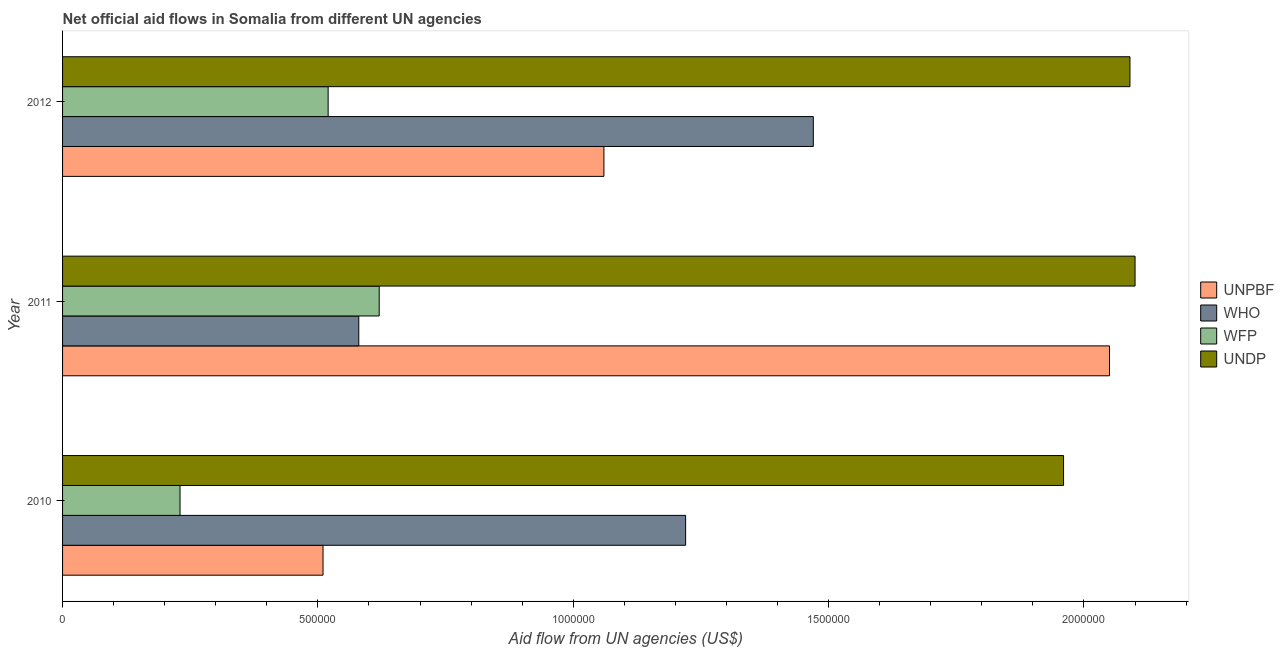How many different coloured bars are there?
Provide a succinct answer. 4. How many groups of bars are there?
Give a very brief answer. 3. Are the number of bars per tick equal to the number of legend labels?
Ensure brevity in your answer.  Yes. Are the number of bars on each tick of the Y-axis equal?
Provide a short and direct response. Yes. How many bars are there on the 3rd tick from the top?
Give a very brief answer. 4. What is the amount of aid given by who in 2010?
Your answer should be very brief. 1.22e+06. Across all years, what is the maximum amount of aid given by wfp?
Make the answer very short. 6.20e+05. Across all years, what is the minimum amount of aid given by undp?
Your response must be concise. 1.96e+06. In which year was the amount of aid given by undp minimum?
Your response must be concise. 2010. What is the total amount of aid given by wfp in the graph?
Keep it short and to the point. 1.37e+06. What is the difference between the amount of aid given by wfp in 2010 and that in 2012?
Offer a very short reply. -2.90e+05. What is the difference between the amount of aid given by unpbf in 2010 and the amount of aid given by wfp in 2011?
Give a very brief answer. -1.10e+05. What is the average amount of aid given by wfp per year?
Offer a very short reply. 4.57e+05. In the year 2012, what is the difference between the amount of aid given by undp and amount of aid given by wfp?
Offer a terse response. 1.57e+06. What is the ratio of the amount of aid given by unpbf in 2010 to that in 2012?
Ensure brevity in your answer.  0.48. Is the amount of aid given by wfp in 2011 less than that in 2012?
Keep it short and to the point. No. What is the difference between the highest and the second highest amount of aid given by undp?
Your response must be concise. 10000. What is the difference between the highest and the lowest amount of aid given by unpbf?
Your response must be concise. 1.54e+06. In how many years, is the amount of aid given by wfp greater than the average amount of aid given by wfp taken over all years?
Your response must be concise. 2. What does the 3rd bar from the top in 2012 represents?
Your response must be concise. WHO. What does the 2nd bar from the bottom in 2011 represents?
Keep it short and to the point. WHO. How many years are there in the graph?
Your answer should be very brief. 3. What is the difference between two consecutive major ticks on the X-axis?
Provide a short and direct response. 5.00e+05. Are the values on the major ticks of X-axis written in scientific E-notation?
Your answer should be very brief. No. Does the graph contain any zero values?
Offer a terse response. No. Does the graph contain grids?
Your response must be concise. No. What is the title of the graph?
Your answer should be very brief. Net official aid flows in Somalia from different UN agencies. What is the label or title of the X-axis?
Give a very brief answer. Aid flow from UN agencies (US$). What is the Aid flow from UN agencies (US$) in UNPBF in 2010?
Provide a short and direct response. 5.10e+05. What is the Aid flow from UN agencies (US$) of WHO in 2010?
Make the answer very short. 1.22e+06. What is the Aid flow from UN agencies (US$) in WFP in 2010?
Offer a very short reply. 2.30e+05. What is the Aid flow from UN agencies (US$) in UNDP in 2010?
Provide a short and direct response. 1.96e+06. What is the Aid flow from UN agencies (US$) in UNPBF in 2011?
Keep it short and to the point. 2.05e+06. What is the Aid flow from UN agencies (US$) in WHO in 2011?
Give a very brief answer. 5.80e+05. What is the Aid flow from UN agencies (US$) in WFP in 2011?
Your answer should be compact. 6.20e+05. What is the Aid flow from UN agencies (US$) in UNDP in 2011?
Your answer should be compact. 2.10e+06. What is the Aid flow from UN agencies (US$) in UNPBF in 2012?
Offer a terse response. 1.06e+06. What is the Aid flow from UN agencies (US$) of WHO in 2012?
Offer a very short reply. 1.47e+06. What is the Aid flow from UN agencies (US$) in WFP in 2012?
Make the answer very short. 5.20e+05. What is the Aid flow from UN agencies (US$) in UNDP in 2012?
Keep it short and to the point. 2.09e+06. Across all years, what is the maximum Aid flow from UN agencies (US$) of UNPBF?
Make the answer very short. 2.05e+06. Across all years, what is the maximum Aid flow from UN agencies (US$) of WHO?
Make the answer very short. 1.47e+06. Across all years, what is the maximum Aid flow from UN agencies (US$) of WFP?
Your answer should be very brief. 6.20e+05. Across all years, what is the maximum Aid flow from UN agencies (US$) in UNDP?
Offer a very short reply. 2.10e+06. Across all years, what is the minimum Aid flow from UN agencies (US$) of UNPBF?
Your answer should be very brief. 5.10e+05. Across all years, what is the minimum Aid flow from UN agencies (US$) in WHO?
Your answer should be compact. 5.80e+05. Across all years, what is the minimum Aid flow from UN agencies (US$) of UNDP?
Ensure brevity in your answer.  1.96e+06. What is the total Aid flow from UN agencies (US$) of UNPBF in the graph?
Offer a very short reply. 3.62e+06. What is the total Aid flow from UN agencies (US$) of WHO in the graph?
Provide a short and direct response. 3.27e+06. What is the total Aid flow from UN agencies (US$) in WFP in the graph?
Your response must be concise. 1.37e+06. What is the total Aid flow from UN agencies (US$) of UNDP in the graph?
Ensure brevity in your answer.  6.15e+06. What is the difference between the Aid flow from UN agencies (US$) in UNPBF in 2010 and that in 2011?
Ensure brevity in your answer.  -1.54e+06. What is the difference between the Aid flow from UN agencies (US$) in WHO in 2010 and that in 2011?
Ensure brevity in your answer.  6.40e+05. What is the difference between the Aid flow from UN agencies (US$) of WFP in 2010 and that in 2011?
Keep it short and to the point. -3.90e+05. What is the difference between the Aid flow from UN agencies (US$) in UNPBF in 2010 and that in 2012?
Your answer should be compact. -5.50e+05. What is the difference between the Aid flow from UN agencies (US$) of WFP in 2010 and that in 2012?
Your answer should be very brief. -2.90e+05. What is the difference between the Aid flow from UN agencies (US$) in UNDP in 2010 and that in 2012?
Ensure brevity in your answer.  -1.30e+05. What is the difference between the Aid flow from UN agencies (US$) in UNPBF in 2011 and that in 2012?
Provide a short and direct response. 9.90e+05. What is the difference between the Aid flow from UN agencies (US$) of WHO in 2011 and that in 2012?
Offer a very short reply. -8.90e+05. What is the difference between the Aid flow from UN agencies (US$) of WFP in 2011 and that in 2012?
Ensure brevity in your answer.  1.00e+05. What is the difference between the Aid flow from UN agencies (US$) in UNPBF in 2010 and the Aid flow from UN agencies (US$) in UNDP in 2011?
Ensure brevity in your answer.  -1.59e+06. What is the difference between the Aid flow from UN agencies (US$) of WHO in 2010 and the Aid flow from UN agencies (US$) of WFP in 2011?
Offer a very short reply. 6.00e+05. What is the difference between the Aid flow from UN agencies (US$) in WHO in 2010 and the Aid flow from UN agencies (US$) in UNDP in 2011?
Provide a succinct answer. -8.80e+05. What is the difference between the Aid flow from UN agencies (US$) in WFP in 2010 and the Aid flow from UN agencies (US$) in UNDP in 2011?
Give a very brief answer. -1.87e+06. What is the difference between the Aid flow from UN agencies (US$) in UNPBF in 2010 and the Aid flow from UN agencies (US$) in WHO in 2012?
Your answer should be very brief. -9.60e+05. What is the difference between the Aid flow from UN agencies (US$) in UNPBF in 2010 and the Aid flow from UN agencies (US$) in WFP in 2012?
Offer a very short reply. -10000. What is the difference between the Aid flow from UN agencies (US$) of UNPBF in 2010 and the Aid flow from UN agencies (US$) of UNDP in 2012?
Your answer should be very brief. -1.58e+06. What is the difference between the Aid flow from UN agencies (US$) in WHO in 2010 and the Aid flow from UN agencies (US$) in UNDP in 2012?
Give a very brief answer. -8.70e+05. What is the difference between the Aid flow from UN agencies (US$) in WFP in 2010 and the Aid flow from UN agencies (US$) in UNDP in 2012?
Offer a very short reply. -1.86e+06. What is the difference between the Aid flow from UN agencies (US$) of UNPBF in 2011 and the Aid flow from UN agencies (US$) of WHO in 2012?
Keep it short and to the point. 5.80e+05. What is the difference between the Aid flow from UN agencies (US$) in UNPBF in 2011 and the Aid flow from UN agencies (US$) in WFP in 2012?
Ensure brevity in your answer.  1.53e+06. What is the difference between the Aid flow from UN agencies (US$) in WHO in 2011 and the Aid flow from UN agencies (US$) in UNDP in 2012?
Your answer should be very brief. -1.51e+06. What is the difference between the Aid flow from UN agencies (US$) of WFP in 2011 and the Aid flow from UN agencies (US$) of UNDP in 2012?
Your response must be concise. -1.47e+06. What is the average Aid flow from UN agencies (US$) of UNPBF per year?
Make the answer very short. 1.21e+06. What is the average Aid flow from UN agencies (US$) in WHO per year?
Provide a short and direct response. 1.09e+06. What is the average Aid flow from UN agencies (US$) in WFP per year?
Provide a succinct answer. 4.57e+05. What is the average Aid flow from UN agencies (US$) of UNDP per year?
Your response must be concise. 2.05e+06. In the year 2010, what is the difference between the Aid flow from UN agencies (US$) of UNPBF and Aid flow from UN agencies (US$) of WHO?
Make the answer very short. -7.10e+05. In the year 2010, what is the difference between the Aid flow from UN agencies (US$) in UNPBF and Aid flow from UN agencies (US$) in UNDP?
Give a very brief answer. -1.45e+06. In the year 2010, what is the difference between the Aid flow from UN agencies (US$) of WHO and Aid flow from UN agencies (US$) of WFP?
Ensure brevity in your answer.  9.90e+05. In the year 2010, what is the difference between the Aid flow from UN agencies (US$) of WHO and Aid flow from UN agencies (US$) of UNDP?
Your answer should be compact. -7.40e+05. In the year 2010, what is the difference between the Aid flow from UN agencies (US$) of WFP and Aid flow from UN agencies (US$) of UNDP?
Provide a succinct answer. -1.73e+06. In the year 2011, what is the difference between the Aid flow from UN agencies (US$) in UNPBF and Aid flow from UN agencies (US$) in WHO?
Offer a terse response. 1.47e+06. In the year 2011, what is the difference between the Aid flow from UN agencies (US$) of UNPBF and Aid flow from UN agencies (US$) of WFP?
Give a very brief answer. 1.43e+06. In the year 2011, what is the difference between the Aid flow from UN agencies (US$) in WHO and Aid flow from UN agencies (US$) in WFP?
Give a very brief answer. -4.00e+04. In the year 2011, what is the difference between the Aid flow from UN agencies (US$) of WHO and Aid flow from UN agencies (US$) of UNDP?
Give a very brief answer. -1.52e+06. In the year 2011, what is the difference between the Aid flow from UN agencies (US$) in WFP and Aid flow from UN agencies (US$) in UNDP?
Offer a very short reply. -1.48e+06. In the year 2012, what is the difference between the Aid flow from UN agencies (US$) of UNPBF and Aid flow from UN agencies (US$) of WHO?
Your answer should be compact. -4.10e+05. In the year 2012, what is the difference between the Aid flow from UN agencies (US$) of UNPBF and Aid flow from UN agencies (US$) of WFP?
Give a very brief answer. 5.40e+05. In the year 2012, what is the difference between the Aid flow from UN agencies (US$) in UNPBF and Aid flow from UN agencies (US$) in UNDP?
Provide a succinct answer. -1.03e+06. In the year 2012, what is the difference between the Aid flow from UN agencies (US$) in WHO and Aid flow from UN agencies (US$) in WFP?
Make the answer very short. 9.50e+05. In the year 2012, what is the difference between the Aid flow from UN agencies (US$) of WHO and Aid flow from UN agencies (US$) of UNDP?
Ensure brevity in your answer.  -6.20e+05. In the year 2012, what is the difference between the Aid flow from UN agencies (US$) in WFP and Aid flow from UN agencies (US$) in UNDP?
Your response must be concise. -1.57e+06. What is the ratio of the Aid flow from UN agencies (US$) in UNPBF in 2010 to that in 2011?
Make the answer very short. 0.25. What is the ratio of the Aid flow from UN agencies (US$) of WHO in 2010 to that in 2011?
Your response must be concise. 2.1. What is the ratio of the Aid flow from UN agencies (US$) of WFP in 2010 to that in 2011?
Your response must be concise. 0.37. What is the ratio of the Aid flow from UN agencies (US$) in UNDP in 2010 to that in 2011?
Your answer should be very brief. 0.93. What is the ratio of the Aid flow from UN agencies (US$) in UNPBF in 2010 to that in 2012?
Provide a succinct answer. 0.48. What is the ratio of the Aid flow from UN agencies (US$) in WHO in 2010 to that in 2012?
Your answer should be compact. 0.83. What is the ratio of the Aid flow from UN agencies (US$) in WFP in 2010 to that in 2012?
Your response must be concise. 0.44. What is the ratio of the Aid flow from UN agencies (US$) in UNDP in 2010 to that in 2012?
Offer a terse response. 0.94. What is the ratio of the Aid flow from UN agencies (US$) in UNPBF in 2011 to that in 2012?
Provide a short and direct response. 1.93. What is the ratio of the Aid flow from UN agencies (US$) of WHO in 2011 to that in 2012?
Offer a very short reply. 0.39. What is the ratio of the Aid flow from UN agencies (US$) in WFP in 2011 to that in 2012?
Give a very brief answer. 1.19. What is the difference between the highest and the second highest Aid flow from UN agencies (US$) in UNPBF?
Your response must be concise. 9.90e+05. What is the difference between the highest and the second highest Aid flow from UN agencies (US$) in WHO?
Your response must be concise. 2.50e+05. What is the difference between the highest and the second highest Aid flow from UN agencies (US$) of WFP?
Your answer should be very brief. 1.00e+05. What is the difference between the highest and the second highest Aid flow from UN agencies (US$) in UNDP?
Keep it short and to the point. 10000. What is the difference between the highest and the lowest Aid flow from UN agencies (US$) in UNPBF?
Provide a short and direct response. 1.54e+06. What is the difference between the highest and the lowest Aid flow from UN agencies (US$) of WHO?
Ensure brevity in your answer.  8.90e+05. What is the difference between the highest and the lowest Aid flow from UN agencies (US$) in WFP?
Ensure brevity in your answer.  3.90e+05. What is the difference between the highest and the lowest Aid flow from UN agencies (US$) of UNDP?
Provide a short and direct response. 1.40e+05. 